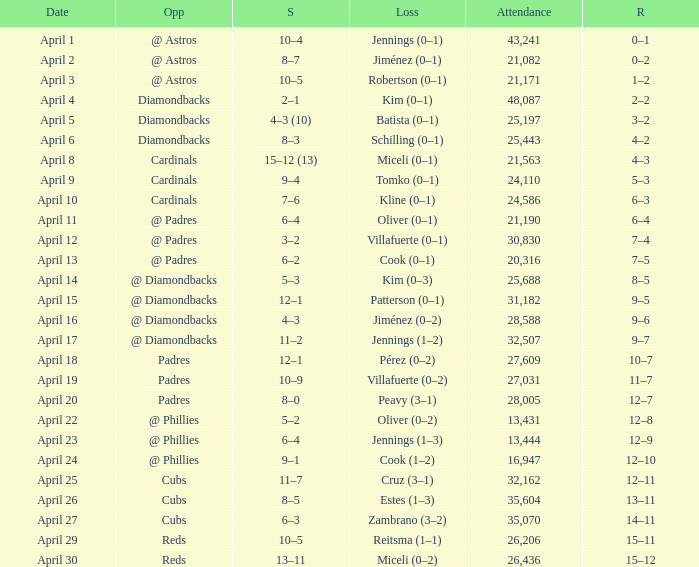Who is the opponent on april 16? @ Diamondbacks. 